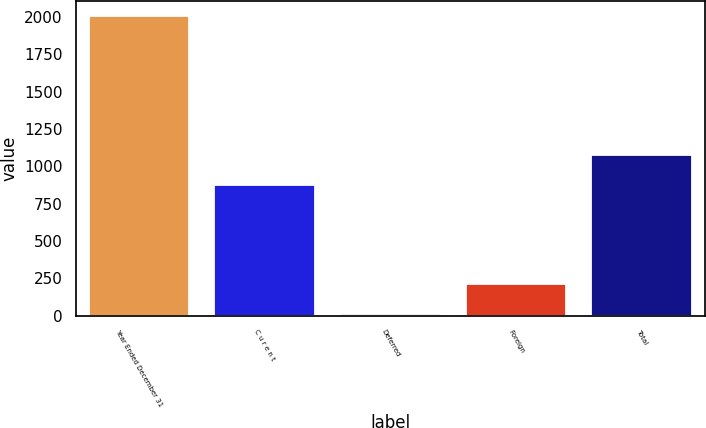Convert chart. <chart><loc_0><loc_0><loc_500><loc_500><bar_chart><fcel>Year Ended December 31<fcel>C u r e n t<fcel>Deferred<fcel>Foreign<fcel>Total<nl><fcel>2007<fcel>876<fcel>12<fcel>211.5<fcel>1075.5<nl></chart> 